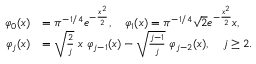Convert formula to latex. <formula><loc_0><loc_0><loc_500><loc_500>\begin{array} { r l } { \varphi _ { 0 } ( x ) } & { = \pi ^ { - 1 / 4 } e ^ { - \frac { x ^ { 2 } } { 2 } } , \quad \varphi _ { 1 } ( x ) = \pi ^ { - 1 / 4 } \sqrt { 2 } e ^ { - \frac { x ^ { 2 } } { 2 } } x , } \\ { \varphi _ { j } ( x ) } & { = \sqrt { \frac { 2 } { j } } \ x \ \varphi _ { j - 1 } ( x ) - \sqrt { \frac { j - 1 } { j } } \ \varphi _ { j - 2 } ( x ) , \quad j \geq 2 . } \end{array}</formula> 